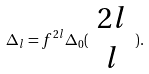<formula> <loc_0><loc_0><loc_500><loc_500>\Delta _ { l } = f ^ { 2 l } \Delta _ { 0 } ( \begin{array} { c } 2 l \\ l \end{array} ) .</formula> 